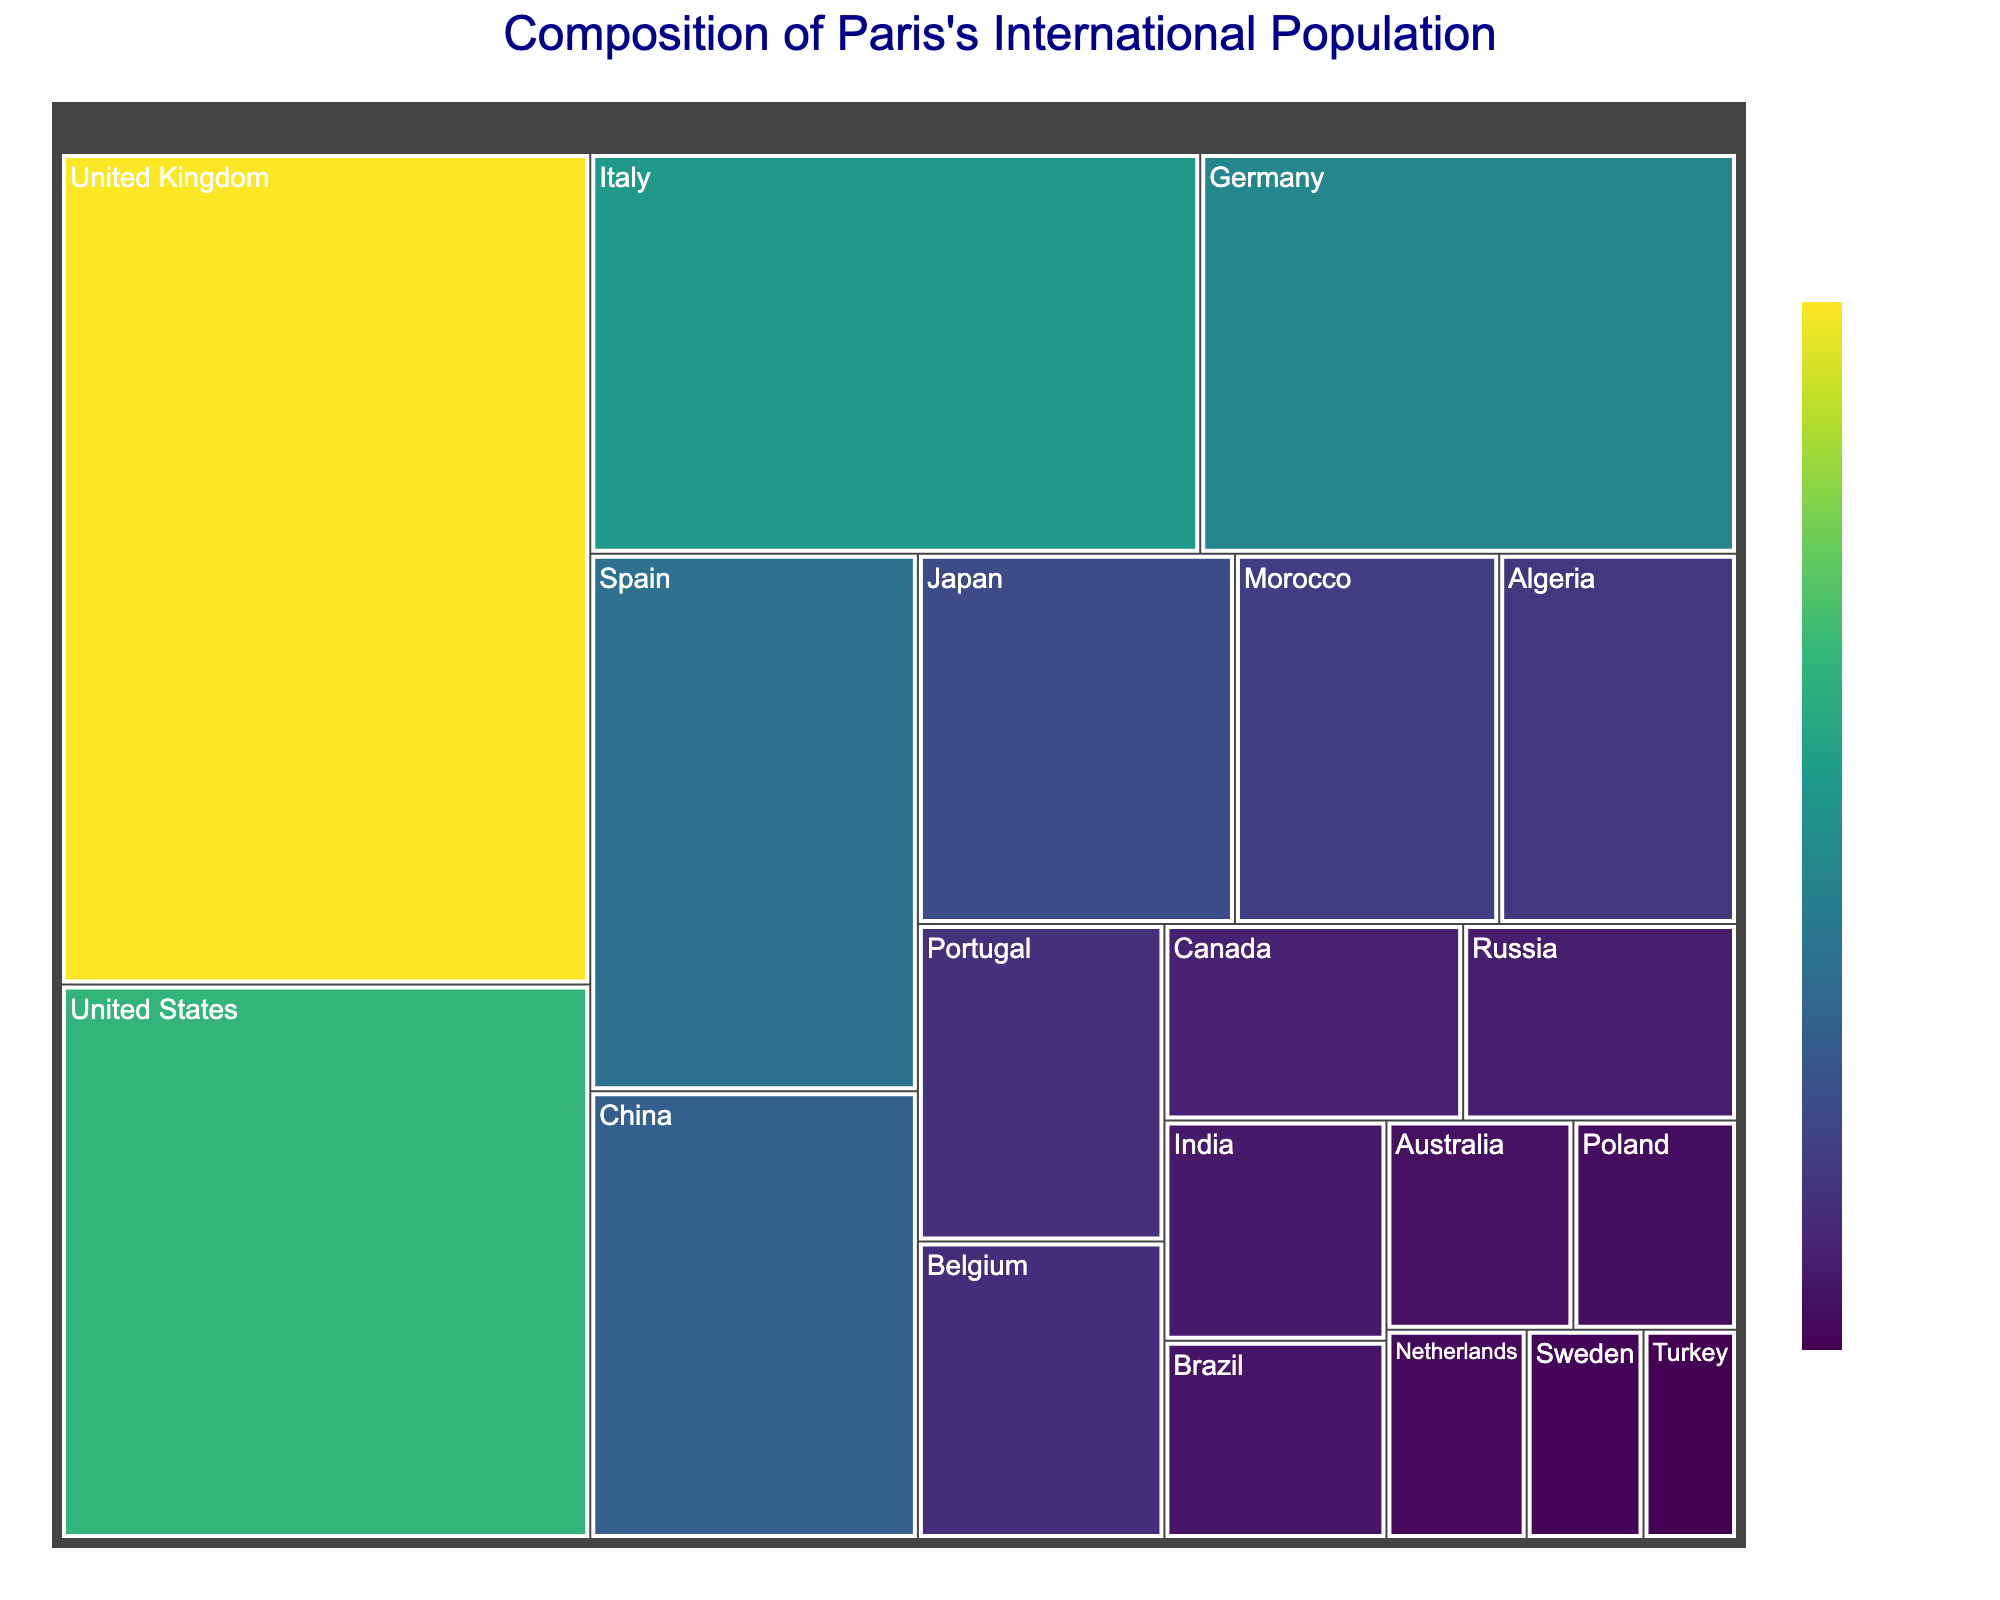What's the title of the Treemap? The title is written at the top of the Treemap and is the focal point to understand the figure's context.
Answer: Composition of Paris's International Population Which country has the highest population in this Treemap? The largest rectangle in the Treemap represents the country with the highest population.
Answer: United Kingdom What is the population of the United States? Hovering over the United States segment on the Treemap or visually identifying the segment's label will reveal the population.
Answer: 30,000 What are the combined populations of China and Japan? Locate and read the populations for both China and Japan, then sum them up: 15,000 + 12,000 = 27,000.
Answer: 27,000 Which country has a larger population: Germany or Italy? Compare the sizes of the rectangles labeled as Germany and Italy and their respective populations. Italy has a population of 25,000, and Germany has a population of 22,000.
Answer: Italy Which country has the smallest population among all listed in the Treemap? The smallest rectangle in the Treemap, which will have the smallest population number.
Answer: Turkey What is the population difference between Spain and Portugal? Determine the population of Spain (18,000) and Portugal (8,000), then subtract: 18,000 - 8,000 = 10,000.
Answer: 10,000 What is the total population represented in the Treemap? Sum up the populations of all the countries listed. The total is 45000 + 30000 + 25000 + 22000 + 18000 + 15000 + 12000 + 10000 + 9000 + 8000 + 7500 + 6000 + 5500 + 5000 + 4500 + 4000 + 3500 + 3000 + 2500 + 2000 = 306,000.
Answer: 306,000 How many countries are represented in this Treemap? Count the number of unique countries listed in the Treemap.
Answer: 20 Which continents have the most represented countries in the Treemap? Identify the continents of the represented countries, count the number of countries in each continent, and compare. Europe has countries like United Kingdom, Italy, Germany, Spain, Portugal, Belgium, Poland, Netherlands, Sweden, while Asia, North Africa, and North America have fewer. Europe has the highest representation.
Answer: Europe 